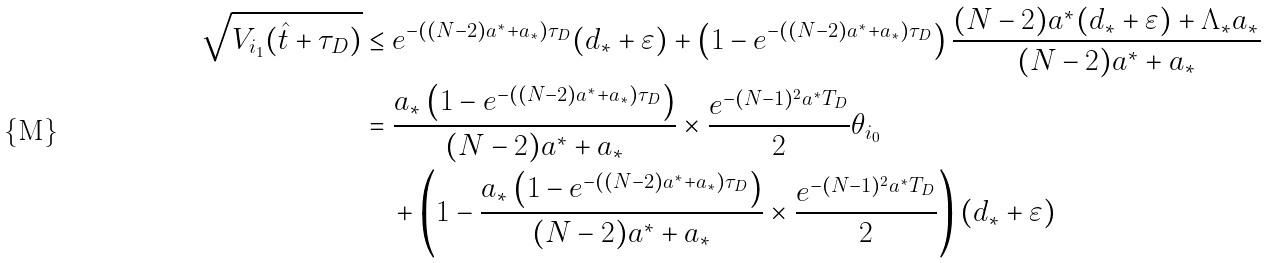<formula> <loc_0><loc_0><loc_500><loc_500>\sqrt { V _ { i _ { 1 } } ( \hat { t } + \tau _ { D } ) } & \leq e ^ { - \left ( ( N - 2 ) a ^ { \ast } + a _ { \ast } \right ) \tau _ { D } } ( d _ { \ast } + \varepsilon ) + \left ( 1 - e ^ { - \left ( ( N - 2 ) a ^ { \ast } + a _ { \ast } \right ) \tau _ { D } } \right ) \frac { ( N - 2 ) a ^ { \ast } ( d _ { \ast } + \varepsilon ) + \Lambda _ { \ast } a _ { \ast } } { ( N - 2 ) a ^ { \ast } + a _ { \ast } } \\ & = \frac { a _ { \ast } \left ( 1 - e ^ { - ( ( N - 2 ) a ^ { \ast } + a _ { \ast } ) \tau _ { D } } \right ) } { ( N - 2 ) a ^ { \ast } + a _ { \ast } } \times \frac { e ^ { - ( N - 1 ) ^ { 2 } a ^ { \ast } T _ { D } } } { 2 } \theta _ { i _ { 0 } } \\ & \quad + \left ( 1 - \frac { a _ { \ast } \left ( 1 - e ^ { - ( ( N - 2 ) a ^ { \ast } + a _ { \ast } ) \tau _ { D } } \right ) } { ( N - 2 ) a ^ { \ast } + a _ { \ast } } \times \frac { e ^ { - ( N - 1 ) ^ { 2 } a ^ { \ast } T _ { D } } } { 2 } \right ) ( d _ { \ast } + \varepsilon )</formula> 